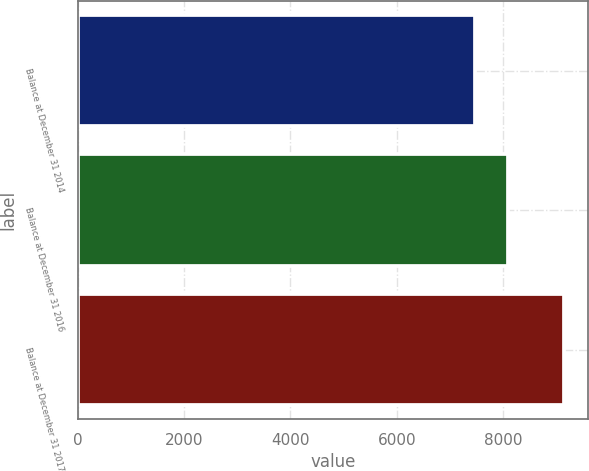Convert chart. <chart><loc_0><loc_0><loc_500><loc_500><bar_chart><fcel>Balance at December 31 2014<fcel>Balance at December 31 2016<fcel>Balance at December 31 2017<nl><fcel>7467<fcel>8094<fcel>9143<nl></chart> 